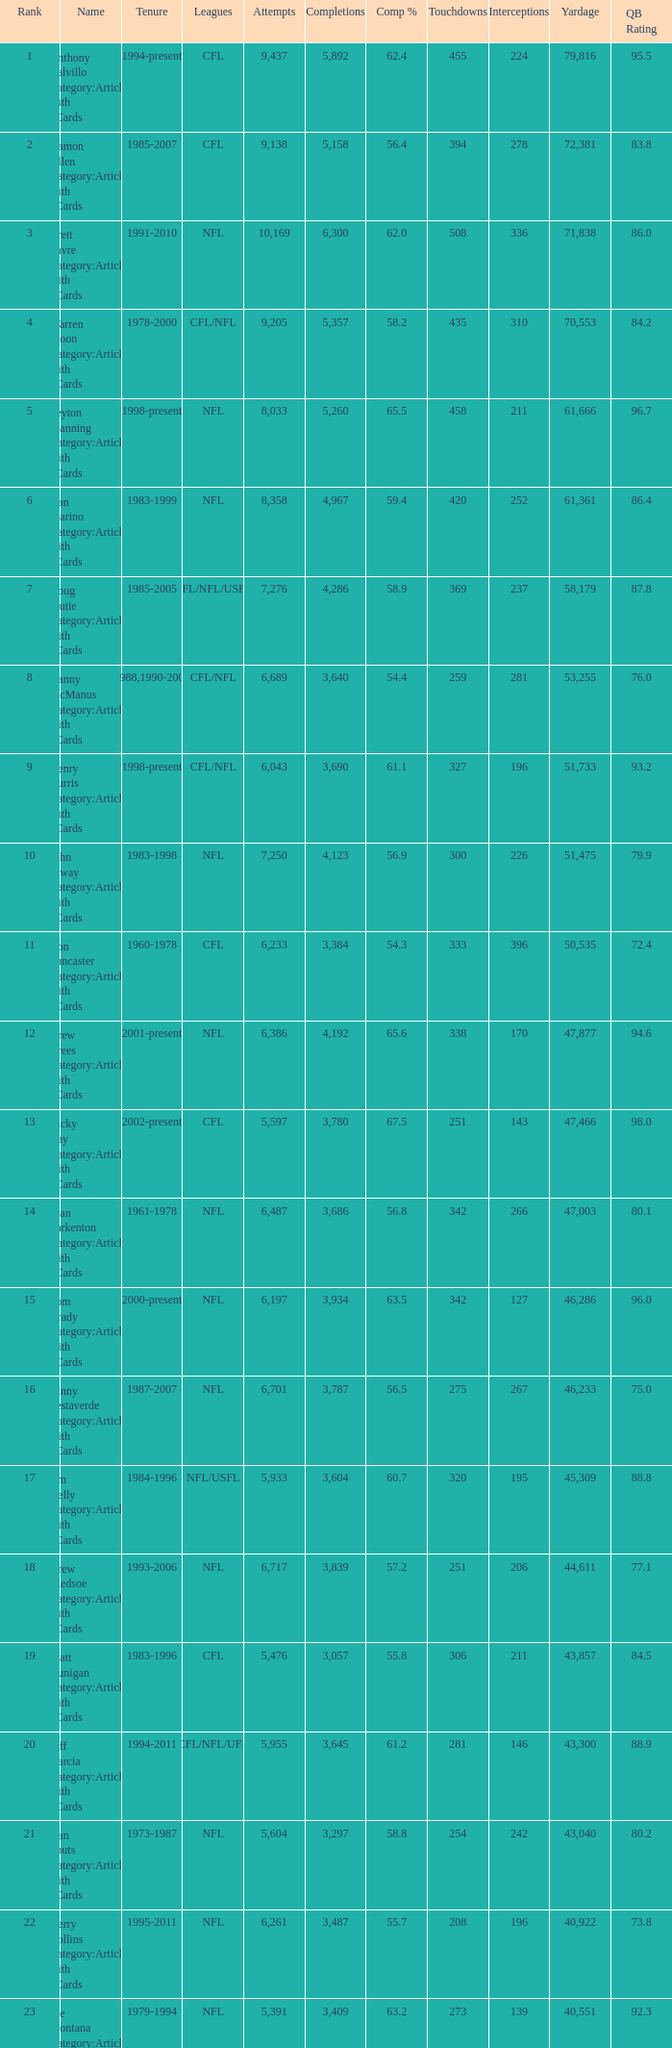With under 3,487 completions, above 40,551 yards, and a completion percentage of 55.8%, what is the count of interceptions? 211.0. 